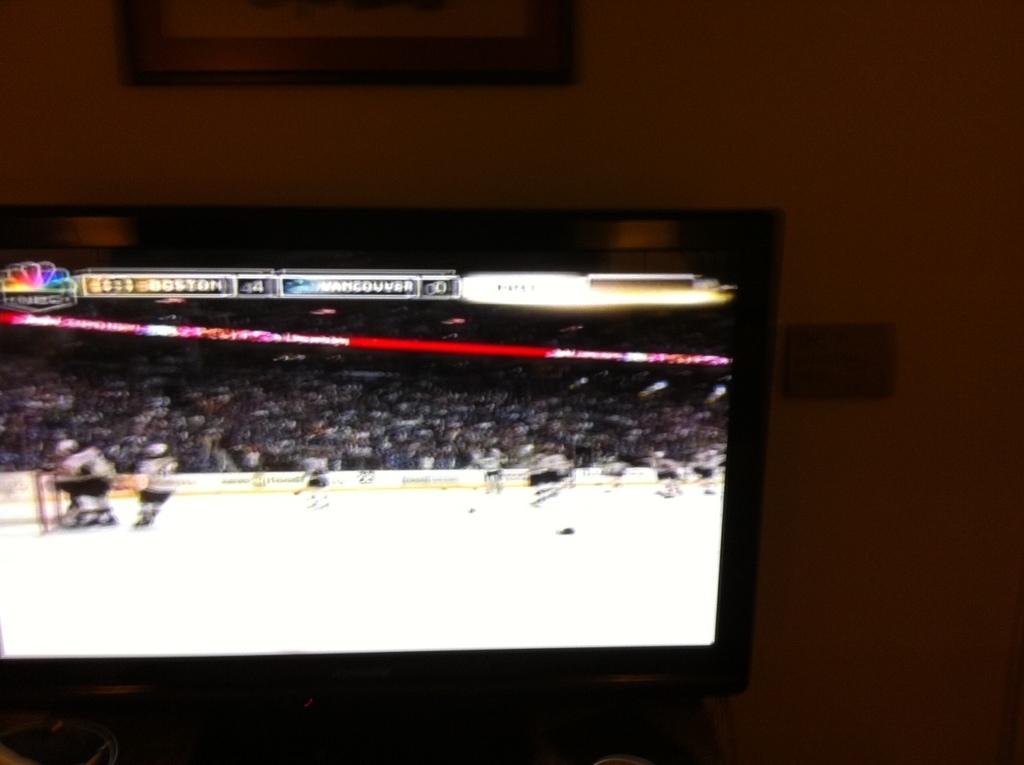What is the main object in the image? There is a screen in the image. What can be seen on the screen? A group of people is visible on the screen. Are there any people present outside of the screen? Yes, there are people on the ground in the image. What else can be seen in the image besides the screen and people? There is text visible in the image. What is in the background of the image? There is a frame on the wall in the background of the image. How many apples are being held by the people on the ground in the image? There is no mention of apples in the image; the people on the ground are not holding any apples. What type of wrist support is being used by the people on the screen? There is no mention of wrist support or any specific activity being performed by the people on the screen. 